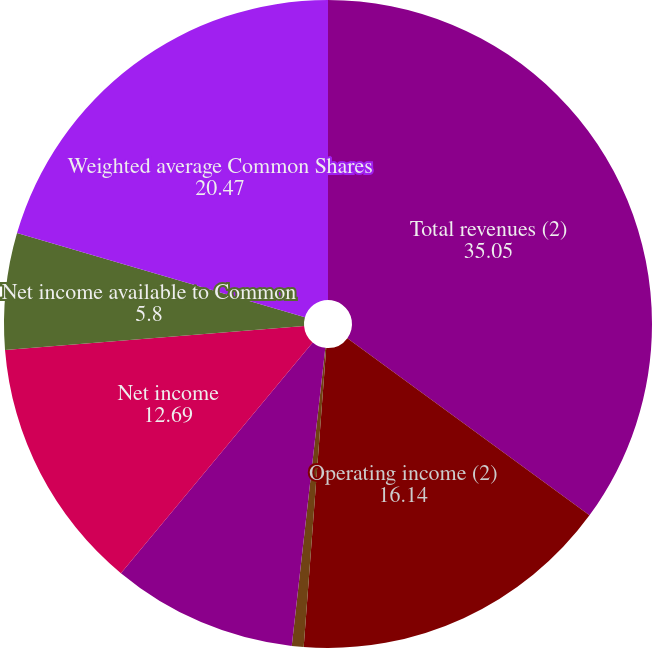Convert chart to OTSL. <chart><loc_0><loc_0><loc_500><loc_500><pie_chart><fcel>Total revenues (2)<fcel>Operating income (2)<fcel>Income (loss) from continuing<fcel>Discontinued operations net<fcel>Net income<fcel>Net income available to Common<fcel>Weighted average Common Shares<nl><fcel>35.05%<fcel>16.14%<fcel>0.59%<fcel>9.25%<fcel>12.69%<fcel>5.8%<fcel>20.47%<nl></chart> 